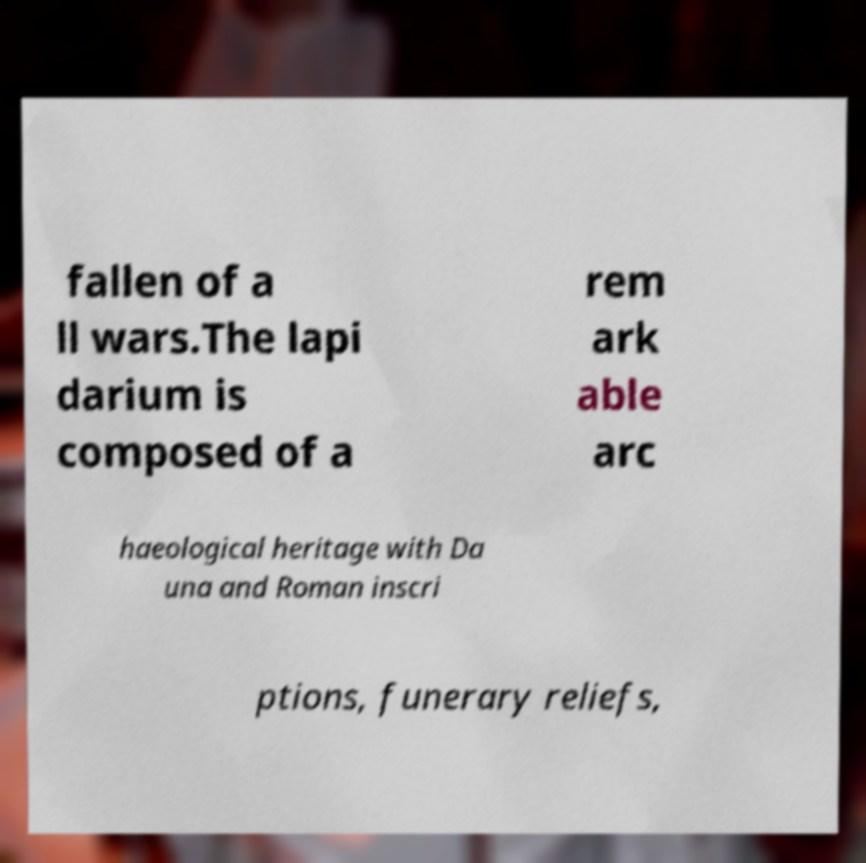Please read and relay the text visible in this image. What does it say? fallen of a ll wars.The lapi darium is composed of a rem ark able arc haeological heritage with Da una and Roman inscri ptions, funerary reliefs, 